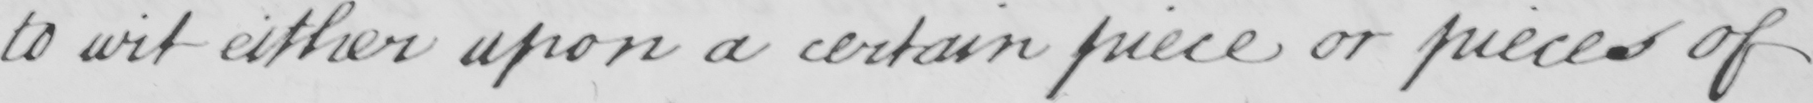What is written in this line of handwriting? to wit either upon a certain piece or pieces of 